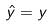<formula> <loc_0><loc_0><loc_500><loc_500>\hat { y } = y</formula> 